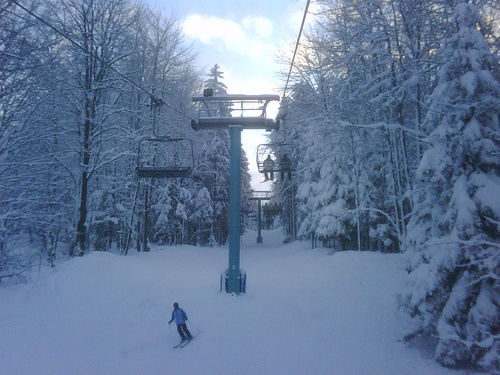Describe the objects in this image and their specific colors. I can see people in gray, navy, blue, and darkblue tones, people in gray, blue, and navy tones, people in gray and darkgray tones, skis in gray and blue tones, and people in blue, gray, black, and darkblue tones in this image. 